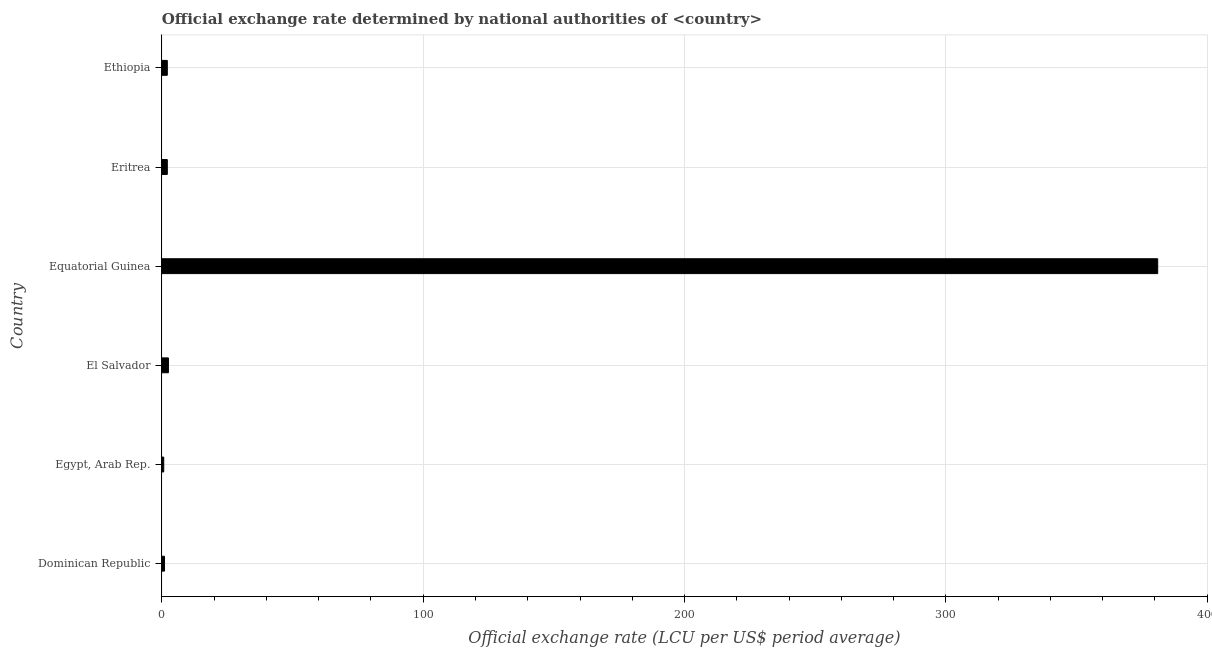What is the title of the graph?
Provide a succinct answer. Official exchange rate determined by national authorities of <country>. What is the label or title of the X-axis?
Offer a very short reply. Official exchange rate (LCU per US$ period average). What is the label or title of the Y-axis?
Your answer should be very brief. Country. What is the official exchange rate in Ethiopia?
Provide a short and direct response. 2.07. Across all countries, what is the maximum official exchange rate?
Ensure brevity in your answer.  381.07. Across all countries, what is the minimum official exchange rate?
Give a very brief answer. 0.7. In which country was the official exchange rate maximum?
Ensure brevity in your answer.  Equatorial Guinea. In which country was the official exchange rate minimum?
Keep it short and to the point. Egypt, Arab Rep. What is the sum of the official exchange rate?
Keep it short and to the point. 389.41. What is the difference between the official exchange rate in Equatorial Guinea and Eritrea?
Ensure brevity in your answer.  378.99. What is the average official exchange rate per country?
Make the answer very short. 64.9. What is the median official exchange rate?
Your answer should be compact. 2.07. What is the ratio of the official exchange rate in Egypt, Arab Rep. to that in Eritrea?
Your response must be concise. 0.34. Is the official exchange rate in Egypt, Arab Rep. less than that in Equatorial Guinea?
Your answer should be compact. Yes. What is the difference between the highest and the second highest official exchange rate?
Ensure brevity in your answer.  378.57. Is the sum of the official exchange rate in Egypt, Arab Rep. and Eritrea greater than the maximum official exchange rate across all countries?
Offer a terse response. No. What is the difference between the highest and the lowest official exchange rate?
Provide a succinct answer. 380.37. In how many countries, is the official exchange rate greater than the average official exchange rate taken over all countries?
Your answer should be very brief. 1. Are all the bars in the graph horizontal?
Make the answer very short. Yes. How many countries are there in the graph?
Offer a very short reply. 6. What is the Official exchange rate (LCU per US$ period average) of Dominican Republic?
Offer a very short reply. 1. What is the Official exchange rate (LCU per US$ period average) in Egypt, Arab Rep.?
Offer a very short reply. 0.7. What is the Official exchange rate (LCU per US$ period average) in Equatorial Guinea?
Keep it short and to the point. 381.07. What is the Official exchange rate (LCU per US$ period average) in Eritrea?
Offer a very short reply. 2.07. What is the Official exchange rate (LCU per US$ period average) of Ethiopia?
Make the answer very short. 2.07. What is the difference between the Official exchange rate (LCU per US$ period average) in Dominican Republic and Egypt, Arab Rep.?
Provide a succinct answer. 0.3. What is the difference between the Official exchange rate (LCU per US$ period average) in Dominican Republic and Equatorial Guinea?
Keep it short and to the point. -380.07. What is the difference between the Official exchange rate (LCU per US$ period average) in Dominican Republic and Eritrea?
Your response must be concise. -1.07. What is the difference between the Official exchange rate (LCU per US$ period average) in Dominican Republic and Ethiopia?
Give a very brief answer. -1.07. What is the difference between the Official exchange rate (LCU per US$ period average) in Egypt, Arab Rep. and El Salvador?
Keep it short and to the point. -1.8. What is the difference between the Official exchange rate (LCU per US$ period average) in Egypt, Arab Rep. and Equatorial Guinea?
Your answer should be compact. -380.37. What is the difference between the Official exchange rate (LCU per US$ period average) in Egypt, Arab Rep. and Eritrea?
Your answer should be compact. -1.37. What is the difference between the Official exchange rate (LCU per US$ period average) in Egypt, Arab Rep. and Ethiopia?
Ensure brevity in your answer.  -1.37. What is the difference between the Official exchange rate (LCU per US$ period average) in El Salvador and Equatorial Guinea?
Provide a short and direct response. -378.57. What is the difference between the Official exchange rate (LCU per US$ period average) in El Salvador and Eritrea?
Your answer should be very brief. 0.43. What is the difference between the Official exchange rate (LCU per US$ period average) in El Salvador and Ethiopia?
Your answer should be very brief. 0.43. What is the difference between the Official exchange rate (LCU per US$ period average) in Equatorial Guinea and Eritrea?
Provide a short and direct response. 378.99. What is the difference between the Official exchange rate (LCU per US$ period average) in Equatorial Guinea and Ethiopia?
Provide a short and direct response. 379. What is the difference between the Official exchange rate (LCU per US$ period average) in Eritrea and Ethiopia?
Your answer should be compact. 0. What is the ratio of the Official exchange rate (LCU per US$ period average) in Dominican Republic to that in Egypt, Arab Rep.?
Provide a succinct answer. 1.43. What is the ratio of the Official exchange rate (LCU per US$ period average) in Dominican Republic to that in El Salvador?
Make the answer very short. 0.4. What is the ratio of the Official exchange rate (LCU per US$ period average) in Dominican Republic to that in Equatorial Guinea?
Ensure brevity in your answer.  0. What is the ratio of the Official exchange rate (LCU per US$ period average) in Dominican Republic to that in Eritrea?
Provide a short and direct response. 0.48. What is the ratio of the Official exchange rate (LCU per US$ period average) in Dominican Republic to that in Ethiopia?
Offer a very short reply. 0.48. What is the ratio of the Official exchange rate (LCU per US$ period average) in Egypt, Arab Rep. to that in El Salvador?
Offer a very short reply. 0.28. What is the ratio of the Official exchange rate (LCU per US$ period average) in Egypt, Arab Rep. to that in Equatorial Guinea?
Give a very brief answer. 0. What is the ratio of the Official exchange rate (LCU per US$ period average) in Egypt, Arab Rep. to that in Eritrea?
Offer a very short reply. 0.34. What is the ratio of the Official exchange rate (LCU per US$ period average) in Egypt, Arab Rep. to that in Ethiopia?
Offer a terse response. 0.34. What is the ratio of the Official exchange rate (LCU per US$ period average) in El Salvador to that in Equatorial Guinea?
Your answer should be very brief. 0.01. What is the ratio of the Official exchange rate (LCU per US$ period average) in El Salvador to that in Eritrea?
Offer a terse response. 1.21. What is the ratio of the Official exchange rate (LCU per US$ period average) in El Salvador to that in Ethiopia?
Ensure brevity in your answer.  1.21. What is the ratio of the Official exchange rate (LCU per US$ period average) in Equatorial Guinea to that in Eritrea?
Your answer should be very brief. 183.91. What is the ratio of the Official exchange rate (LCU per US$ period average) in Equatorial Guinea to that in Ethiopia?
Make the answer very short. 184.09. What is the ratio of the Official exchange rate (LCU per US$ period average) in Eritrea to that in Ethiopia?
Keep it short and to the point. 1. 